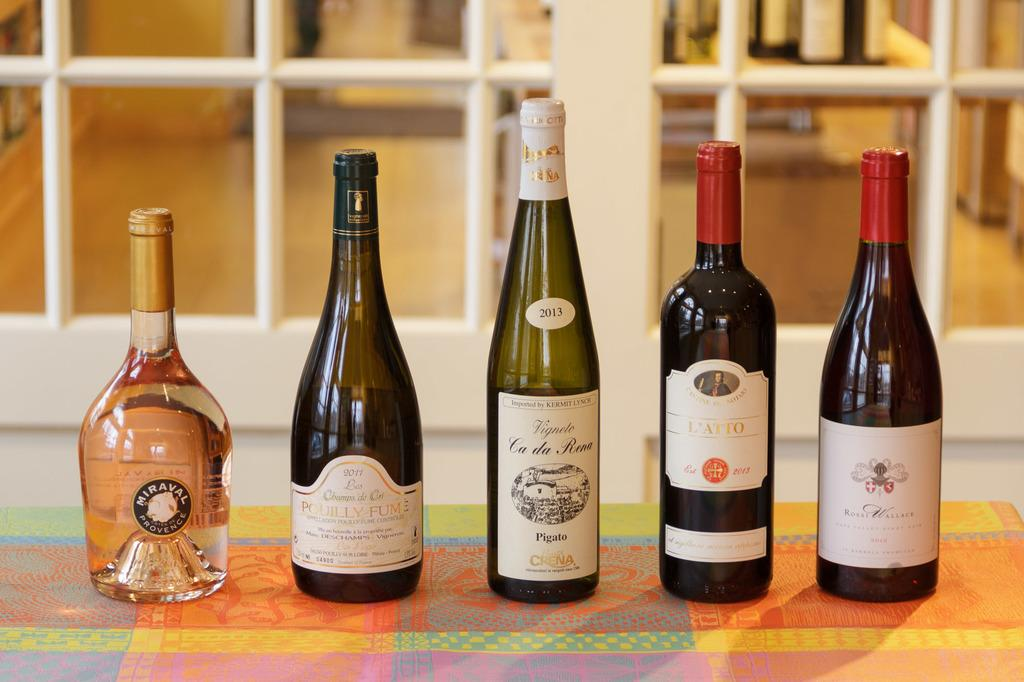<image>
Relay a brief, clear account of the picture shown. An assortment of five different liquor bottles, like Miraval and Ca da Rena, are set up side by side. 